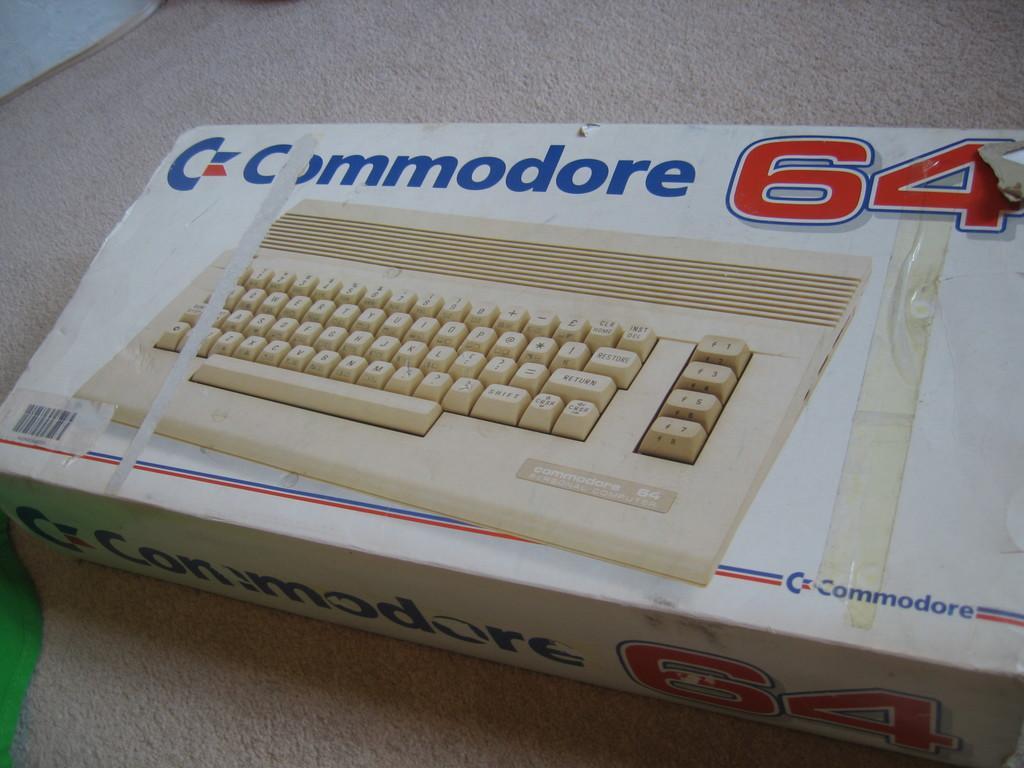Can you describe this image briefly? In this image, I can see the picture of the keyboard on the cardboard box. This looks like a barcode. This cardboard box is placed on the floor. 